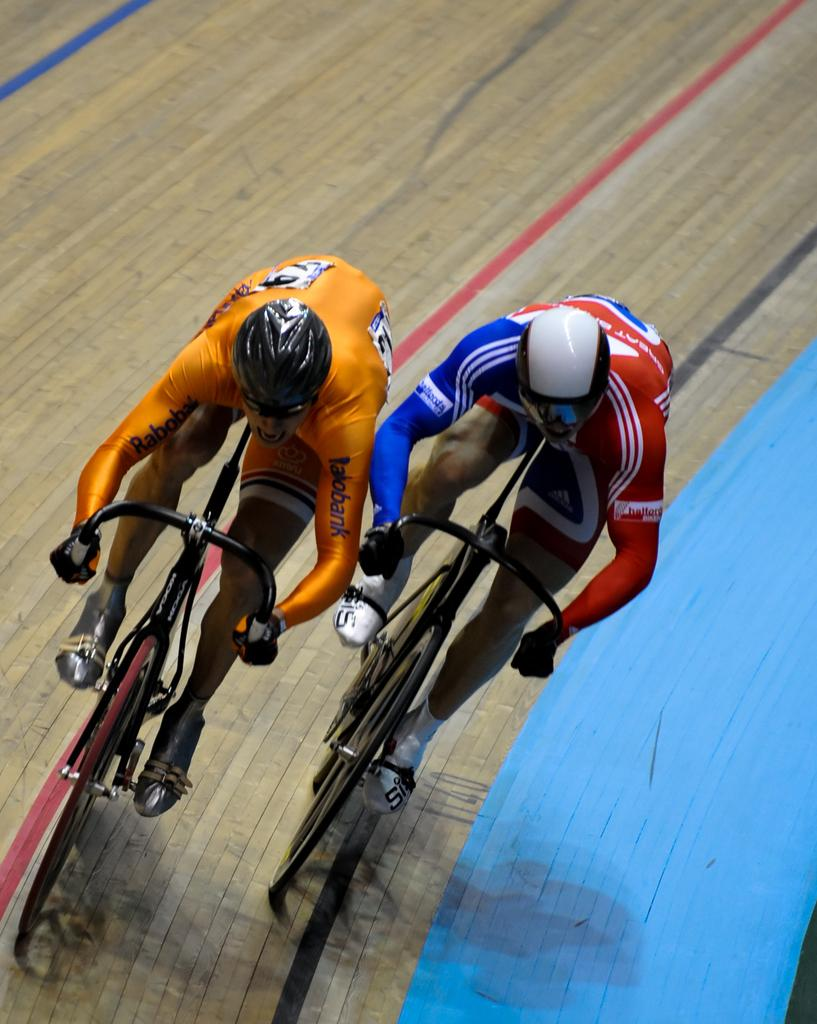How many people are in the image? There are two persons in the image. What are the persons doing in the image? The persons are cycling. Where are the persons cycling? The cycling is taking place on a racetrack. What type of toothpaste is the person on the left using while cycling? There is no toothpaste present in the image, and the persons are not using any while cycling. 